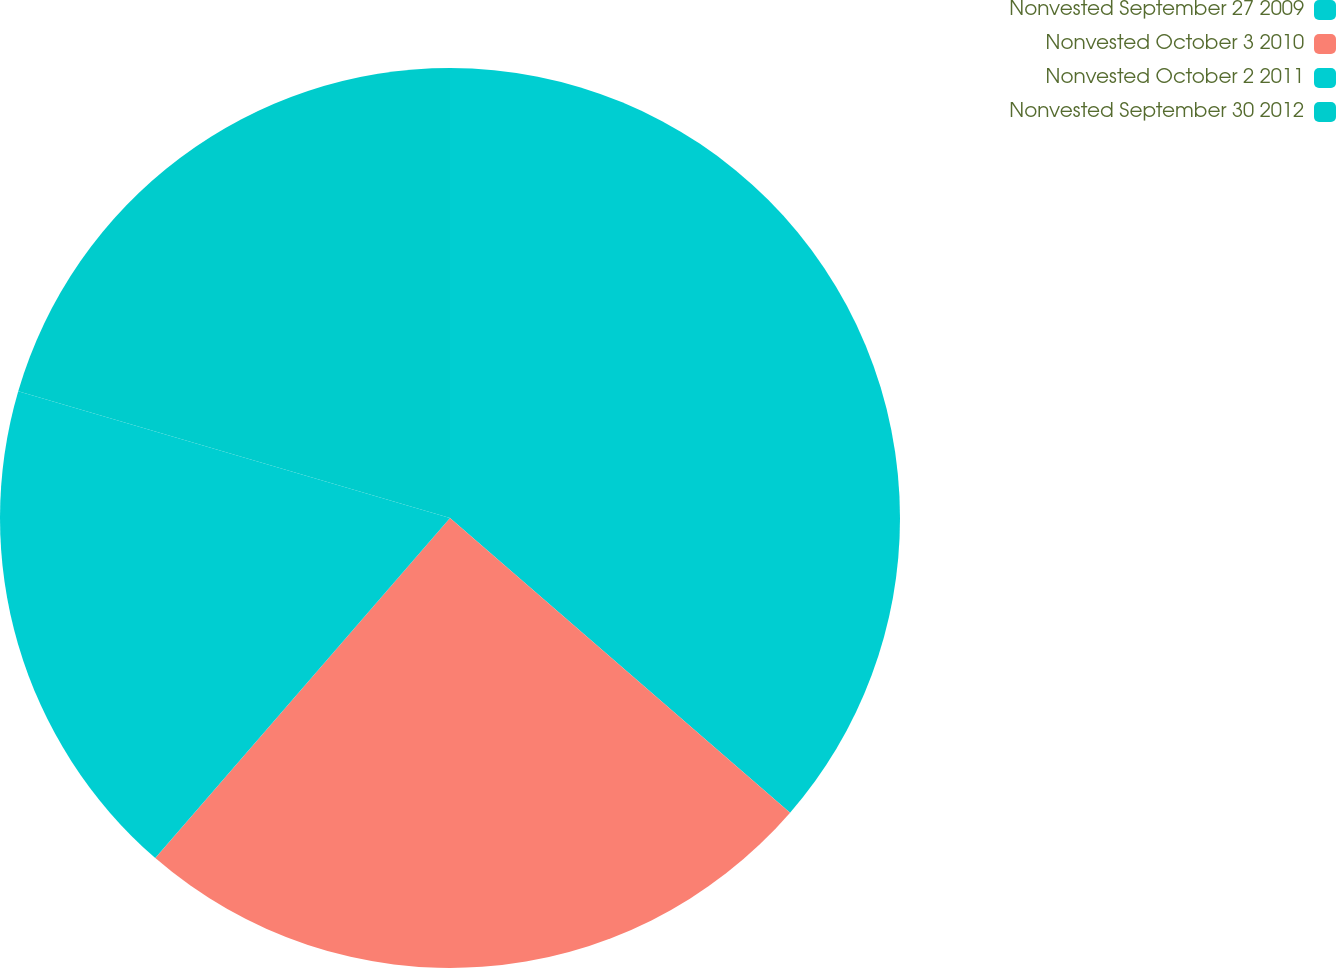Convert chart. <chart><loc_0><loc_0><loc_500><loc_500><pie_chart><fcel>Nonvested September 27 2009<fcel>Nonvested October 3 2010<fcel>Nonvested October 2 2011<fcel>Nonvested September 30 2012<nl><fcel>36.36%<fcel>25.0%<fcel>18.18%<fcel>20.45%<nl></chart> 